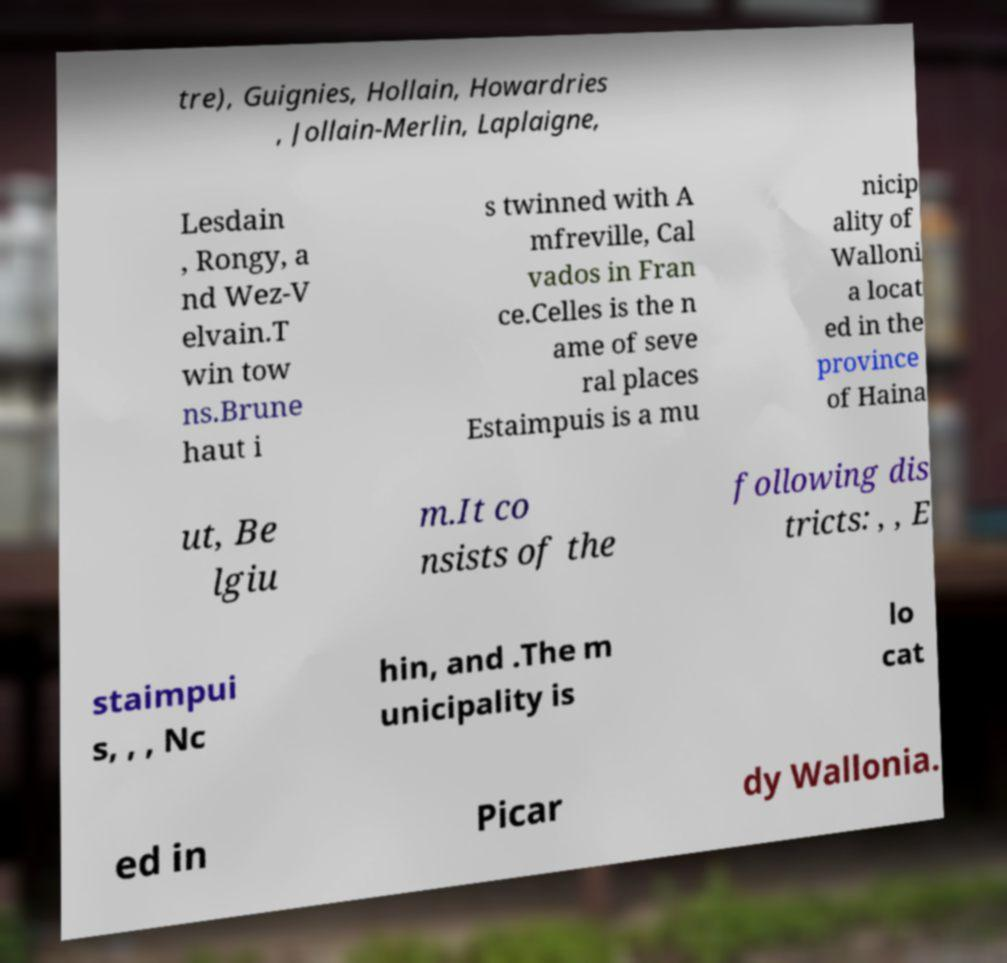Can you accurately transcribe the text from the provided image for me? tre), Guignies, Hollain, Howardries , Jollain-Merlin, Laplaigne, Lesdain , Rongy, a nd Wez-V elvain.T win tow ns.Brune haut i s twinned with A mfreville, Cal vados in Fran ce.Celles is the n ame of seve ral places Estaimpuis is a mu nicip ality of Walloni a locat ed in the province of Haina ut, Be lgiu m.It co nsists of the following dis tricts: , , E staimpui s, , , Nc hin, and .The m unicipality is lo cat ed in Picar dy Wallonia. 